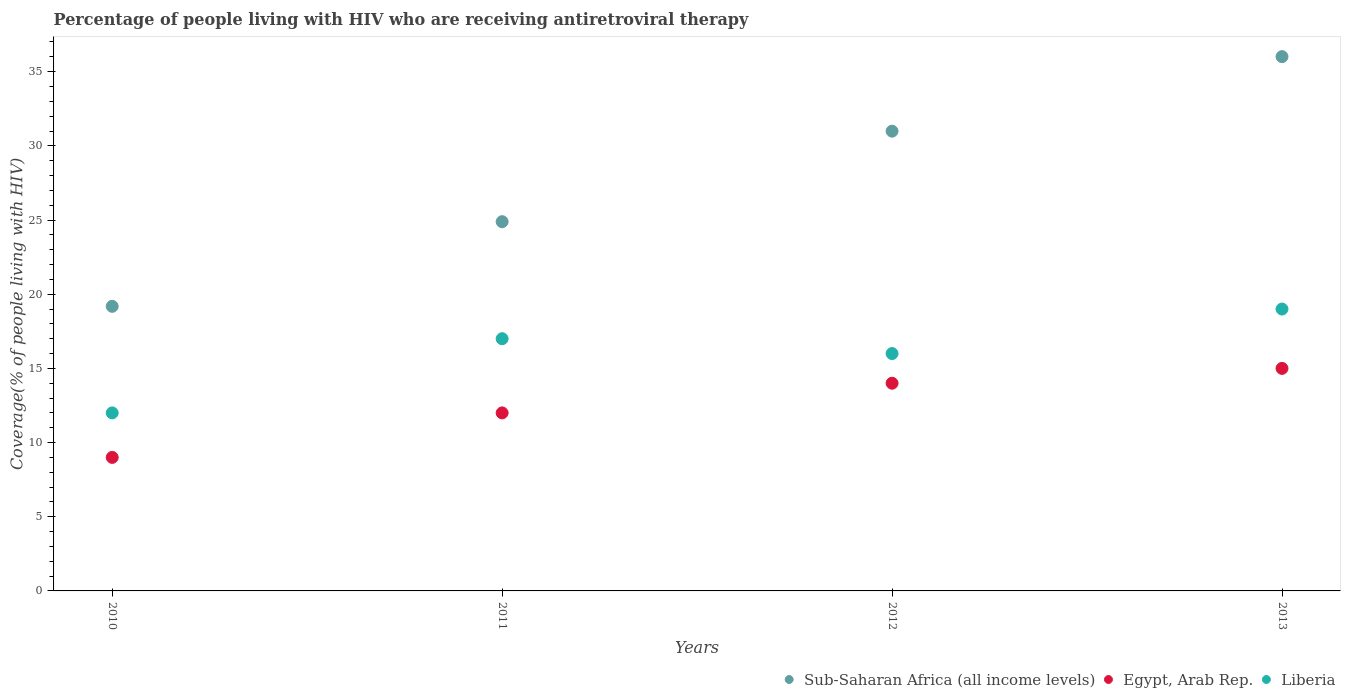How many different coloured dotlines are there?
Offer a very short reply. 3. What is the percentage of the HIV infected people who are receiving antiretroviral therapy in Egypt, Arab Rep. in 2013?
Ensure brevity in your answer.  15. Across all years, what is the maximum percentage of the HIV infected people who are receiving antiretroviral therapy in Sub-Saharan Africa (all income levels)?
Ensure brevity in your answer.  36.01. Across all years, what is the minimum percentage of the HIV infected people who are receiving antiretroviral therapy in Sub-Saharan Africa (all income levels)?
Give a very brief answer. 19.18. In which year was the percentage of the HIV infected people who are receiving antiretroviral therapy in Sub-Saharan Africa (all income levels) minimum?
Make the answer very short. 2010. What is the total percentage of the HIV infected people who are receiving antiretroviral therapy in Sub-Saharan Africa (all income levels) in the graph?
Offer a terse response. 111.08. What is the difference between the percentage of the HIV infected people who are receiving antiretroviral therapy in Liberia in 2011 and that in 2012?
Provide a short and direct response. 1. What is the difference between the percentage of the HIV infected people who are receiving antiretroviral therapy in Sub-Saharan Africa (all income levels) in 2011 and the percentage of the HIV infected people who are receiving antiretroviral therapy in Egypt, Arab Rep. in 2010?
Provide a succinct answer. 15.89. In the year 2012, what is the difference between the percentage of the HIV infected people who are receiving antiretroviral therapy in Liberia and percentage of the HIV infected people who are receiving antiretroviral therapy in Sub-Saharan Africa (all income levels)?
Keep it short and to the point. -14.99. What is the ratio of the percentage of the HIV infected people who are receiving antiretroviral therapy in Liberia in 2010 to that in 2011?
Your answer should be compact. 0.71. Is the percentage of the HIV infected people who are receiving antiretroviral therapy in Sub-Saharan Africa (all income levels) in 2010 less than that in 2012?
Offer a very short reply. Yes. What is the difference between the highest and the second highest percentage of the HIV infected people who are receiving antiretroviral therapy in Egypt, Arab Rep.?
Keep it short and to the point. 1. What is the difference between the highest and the lowest percentage of the HIV infected people who are receiving antiretroviral therapy in Liberia?
Provide a succinct answer. 7. Does the percentage of the HIV infected people who are receiving antiretroviral therapy in Egypt, Arab Rep. monotonically increase over the years?
Your response must be concise. Yes. Is the percentage of the HIV infected people who are receiving antiretroviral therapy in Sub-Saharan Africa (all income levels) strictly greater than the percentage of the HIV infected people who are receiving antiretroviral therapy in Egypt, Arab Rep. over the years?
Keep it short and to the point. Yes. Is the percentage of the HIV infected people who are receiving antiretroviral therapy in Egypt, Arab Rep. strictly less than the percentage of the HIV infected people who are receiving antiretroviral therapy in Liberia over the years?
Your answer should be compact. Yes. How many years are there in the graph?
Provide a short and direct response. 4. Are the values on the major ticks of Y-axis written in scientific E-notation?
Ensure brevity in your answer.  No. Does the graph contain any zero values?
Give a very brief answer. No. Does the graph contain grids?
Your answer should be very brief. No. How are the legend labels stacked?
Make the answer very short. Horizontal. What is the title of the graph?
Provide a succinct answer. Percentage of people living with HIV who are receiving antiretroviral therapy. Does "Isle of Man" appear as one of the legend labels in the graph?
Offer a very short reply. No. What is the label or title of the X-axis?
Keep it short and to the point. Years. What is the label or title of the Y-axis?
Your answer should be compact. Coverage(% of people living with HIV). What is the Coverage(% of people living with HIV) of Sub-Saharan Africa (all income levels) in 2010?
Your answer should be compact. 19.18. What is the Coverage(% of people living with HIV) of Egypt, Arab Rep. in 2010?
Your answer should be compact. 9. What is the Coverage(% of people living with HIV) of Liberia in 2010?
Give a very brief answer. 12. What is the Coverage(% of people living with HIV) of Sub-Saharan Africa (all income levels) in 2011?
Make the answer very short. 24.89. What is the Coverage(% of people living with HIV) in Egypt, Arab Rep. in 2011?
Offer a very short reply. 12. What is the Coverage(% of people living with HIV) in Sub-Saharan Africa (all income levels) in 2012?
Give a very brief answer. 30.99. What is the Coverage(% of people living with HIV) of Sub-Saharan Africa (all income levels) in 2013?
Ensure brevity in your answer.  36.01. What is the Coverage(% of people living with HIV) in Liberia in 2013?
Your answer should be very brief. 19. Across all years, what is the maximum Coverage(% of people living with HIV) in Sub-Saharan Africa (all income levels)?
Your response must be concise. 36.01. Across all years, what is the maximum Coverage(% of people living with HIV) in Liberia?
Ensure brevity in your answer.  19. Across all years, what is the minimum Coverage(% of people living with HIV) in Sub-Saharan Africa (all income levels)?
Provide a succinct answer. 19.18. Across all years, what is the minimum Coverage(% of people living with HIV) of Liberia?
Make the answer very short. 12. What is the total Coverage(% of people living with HIV) in Sub-Saharan Africa (all income levels) in the graph?
Your answer should be compact. 111.08. What is the difference between the Coverage(% of people living with HIV) in Sub-Saharan Africa (all income levels) in 2010 and that in 2011?
Give a very brief answer. -5.71. What is the difference between the Coverage(% of people living with HIV) in Egypt, Arab Rep. in 2010 and that in 2011?
Your response must be concise. -3. What is the difference between the Coverage(% of people living with HIV) of Sub-Saharan Africa (all income levels) in 2010 and that in 2012?
Keep it short and to the point. -11.81. What is the difference between the Coverage(% of people living with HIV) of Egypt, Arab Rep. in 2010 and that in 2012?
Keep it short and to the point. -5. What is the difference between the Coverage(% of people living with HIV) in Sub-Saharan Africa (all income levels) in 2010 and that in 2013?
Keep it short and to the point. -16.83. What is the difference between the Coverage(% of people living with HIV) of Sub-Saharan Africa (all income levels) in 2011 and that in 2012?
Your answer should be very brief. -6.1. What is the difference between the Coverage(% of people living with HIV) in Liberia in 2011 and that in 2012?
Make the answer very short. 1. What is the difference between the Coverage(% of people living with HIV) in Sub-Saharan Africa (all income levels) in 2011 and that in 2013?
Provide a short and direct response. -11.13. What is the difference between the Coverage(% of people living with HIV) of Liberia in 2011 and that in 2013?
Your answer should be very brief. -2. What is the difference between the Coverage(% of people living with HIV) in Sub-Saharan Africa (all income levels) in 2012 and that in 2013?
Keep it short and to the point. -5.03. What is the difference between the Coverage(% of people living with HIV) of Egypt, Arab Rep. in 2012 and that in 2013?
Offer a terse response. -1. What is the difference between the Coverage(% of people living with HIV) in Liberia in 2012 and that in 2013?
Keep it short and to the point. -3. What is the difference between the Coverage(% of people living with HIV) of Sub-Saharan Africa (all income levels) in 2010 and the Coverage(% of people living with HIV) of Egypt, Arab Rep. in 2011?
Your answer should be very brief. 7.18. What is the difference between the Coverage(% of people living with HIV) in Sub-Saharan Africa (all income levels) in 2010 and the Coverage(% of people living with HIV) in Liberia in 2011?
Offer a very short reply. 2.18. What is the difference between the Coverage(% of people living with HIV) of Sub-Saharan Africa (all income levels) in 2010 and the Coverage(% of people living with HIV) of Egypt, Arab Rep. in 2012?
Ensure brevity in your answer.  5.18. What is the difference between the Coverage(% of people living with HIV) in Sub-Saharan Africa (all income levels) in 2010 and the Coverage(% of people living with HIV) in Liberia in 2012?
Keep it short and to the point. 3.18. What is the difference between the Coverage(% of people living with HIV) of Egypt, Arab Rep. in 2010 and the Coverage(% of people living with HIV) of Liberia in 2012?
Keep it short and to the point. -7. What is the difference between the Coverage(% of people living with HIV) in Sub-Saharan Africa (all income levels) in 2010 and the Coverage(% of people living with HIV) in Egypt, Arab Rep. in 2013?
Give a very brief answer. 4.18. What is the difference between the Coverage(% of people living with HIV) in Sub-Saharan Africa (all income levels) in 2010 and the Coverage(% of people living with HIV) in Liberia in 2013?
Offer a very short reply. 0.18. What is the difference between the Coverage(% of people living with HIV) of Egypt, Arab Rep. in 2010 and the Coverage(% of people living with HIV) of Liberia in 2013?
Your response must be concise. -10. What is the difference between the Coverage(% of people living with HIV) of Sub-Saharan Africa (all income levels) in 2011 and the Coverage(% of people living with HIV) of Egypt, Arab Rep. in 2012?
Your answer should be compact. 10.89. What is the difference between the Coverage(% of people living with HIV) of Sub-Saharan Africa (all income levels) in 2011 and the Coverage(% of people living with HIV) of Liberia in 2012?
Give a very brief answer. 8.89. What is the difference between the Coverage(% of people living with HIV) in Egypt, Arab Rep. in 2011 and the Coverage(% of people living with HIV) in Liberia in 2012?
Your answer should be compact. -4. What is the difference between the Coverage(% of people living with HIV) in Sub-Saharan Africa (all income levels) in 2011 and the Coverage(% of people living with HIV) in Egypt, Arab Rep. in 2013?
Offer a very short reply. 9.89. What is the difference between the Coverage(% of people living with HIV) in Sub-Saharan Africa (all income levels) in 2011 and the Coverage(% of people living with HIV) in Liberia in 2013?
Provide a short and direct response. 5.89. What is the difference between the Coverage(% of people living with HIV) of Egypt, Arab Rep. in 2011 and the Coverage(% of people living with HIV) of Liberia in 2013?
Your answer should be compact. -7. What is the difference between the Coverage(% of people living with HIV) in Sub-Saharan Africa (all income levels) in 2012 and the Coverage(% of people living with HIV) in Egypt, Arab Rep. in 2013?
Keep it short and to the point. 15.99. What is the difference between the Coverage(% of people living with HIV) of Sub-Saharan Africa (all income levels) in 2012 and the Coverage(% of people living with HIV) of Liberia in 2013?
Your answer should be compact. 11.99. What is the difference between the Coverage(% of people living with HIV) of Egypt, Arab Rep. in 2012 and the Coverage(% of people living with HIV) of Liberia in 2013?
Offer a very short reply. -5. What is the average Coverage(% of people living with HIV) in Sub-Saharan Africa (all income levels) per year?
Give a very brief answer. 27.77. What is the average Coverage(% of people living with HIV) in Liberia per year?
Make the answer very short. 16. In the year 2010, what is the difference between the Coverage(% of people living with HIV) in Sub-Saharan Africa (all income levels) and Coverage(% of people living with HIV) in Egypt, Arab Rep.?
Provide a short and direct response. 10.18. In the year 2010, what is the difference between the Coverage(% of people living with HIV) in Sub-Saharan Africa (all income levels) and Coverage(% of people living with HIV) in Liberia?
Your answer should be compact. 7.18. In the year 2011, what is the difference between the Coverage(% of people living with HIV) of Sub-Saharan Africa (all income levels) and Coverage(% of people living with HIV) of Egypt, Arab Rep.?
Give a very brief answer. 12.89. In the year 2011, what is the difference between the Coverage(% of people living with HIV) in Sub-Saharan Africa (all income levels) and Coverage(% of people living with HIV) in Liberia?
Your response must be concise. 7.89. In the year 2012, what is the difference between the Coverage(% of people living with HIV) of Sub-Saharan Africa (all income levels) and Coverage(% of people living with HIV) of Egypt, Arab Rep.?
Provide a succinct answer. 16.99. In the year 2012, what is the difference between the Coverage(% of people living with HIV) in Sub-Saharan Africa (all income levels) and Coverage(% of people living with HIV) in Liberia?
Your answer should be very brief. 14.99. In the year 2013, what is the difference between the Coverage(% of people living with HIV) of Sub-Saharan Africa (all income levels) and Coverage(% of people living with HIV) of Egypt, Arab Rep.?
Your answer should be very brief. 21.01. In the year 2013, what is the difference between the Coverage(% of people living with HIV) in Sub-Saharan Africa (all income levels) and Coverage(% of people living with HIV) in Liberia?
Give a very brief answer. 17.01. What is the ratio of the Coverage(% of people living with HIV) of Sub-Saharan Africa (all income levels) in 2010 to that in 2011?
Make the answer very short. 0.77. What is the ratio of the Coverage(% of people living with HIV) in Egypt, Arab Rep. in 2010 to that in 2011?
Offer a very short reply. 0.75. What is the ratio of the Coverage(% of people living with HIV) of Liberia in 2010 to that in 2011?
Your answer should be compact. 0.71. What is the ratio of the Coverage(% of people living with HIV) of Sub-Saharan Africa (all income levels) in 2010 to that in 2012?
Give a very brief answer. 0.62. What is the ratio of the Coverage(% of people living with HIV) of Egypt, Arab Rep. in 2010 to that in 2012?
Provide a short and direct response. 0.64. What is the ratio of the Coverage(% of people living with HIV) in Sub-Saharan Africa (all income levels) in 2010 to that in 2013?
Your response must be concise. 0.53. What is the ratio of the Coverage(% of people living with HIV) in Egypt, Arab Rep. in 2010 to that in 2013?
Provide a succinct answer. 0.6. What is the ratio of the Coverage(% of people living with HIV) in Liberia in 2010 to that in 2013?
Ensure brevity in your answer.  0.63. What is the ratio of the Coverage(% of people living with HIV) in Sub-Saharan Africa (all income levels) in 2011 to that in 2012?
Your response must be concise. 0.8. What is the ratio of the Coverage(% of people living with HIV) of Egypt, Arab Rep. in 2011 to that in 2012?
Your answer should be very brief. 0.86. What is the ratio of the Coverage(% of people living with HIV) in Liberia in 2011 to that in 2012?
Your answer should be very brief. 1.06. What is the ratio of the Coverage(% of people living with HIV) of Sub-Saharan Africa (all income levels) in 2011 to that in 2013?
Your response must be concise. 0.69. What is the ratio of the Coverage(% of people living with HIV) of Liberia in 2011 to that in 2013?
Offer a terse response. 0.89. What is the ratio of the Coverage(% of people living with HIV) of Sub-Saharan Africa (all income levels) in 2012 to that in 2013?
Provide a short and direct response. 0.86. What is the ratio of the Coverage(% of people living with HIV) in Egypt, Arab Rep. in 2012 to that in 2013?
Give a very brief answer. 0.93. What is the ratio of the Coverage(% of people living with HIV) in Liberia in 2012 to that in 2013?
Your answer should be compact. 0.84. What is the difference between the highest and the second highest Coverage(% of people living with HIV) in Sub-Saharan Africa (all income levels)?
Your response must be concise. 5.03. What is the difference between the highest and the second highest Coverage(% of people living with HIV) of Liberia?
Ensure brevity in your answer.  2. What is the difference between the highest and the lowest Coverage(% of people living with HIV) of Sub-Saharan Africa (all income levels)?
Make the answer very short. 16.83. What is the difference between the highest and the lowest Coverage(% of people living with HIV) in Egypt, Arab Rep.?
Your answer should be compact. 6. 